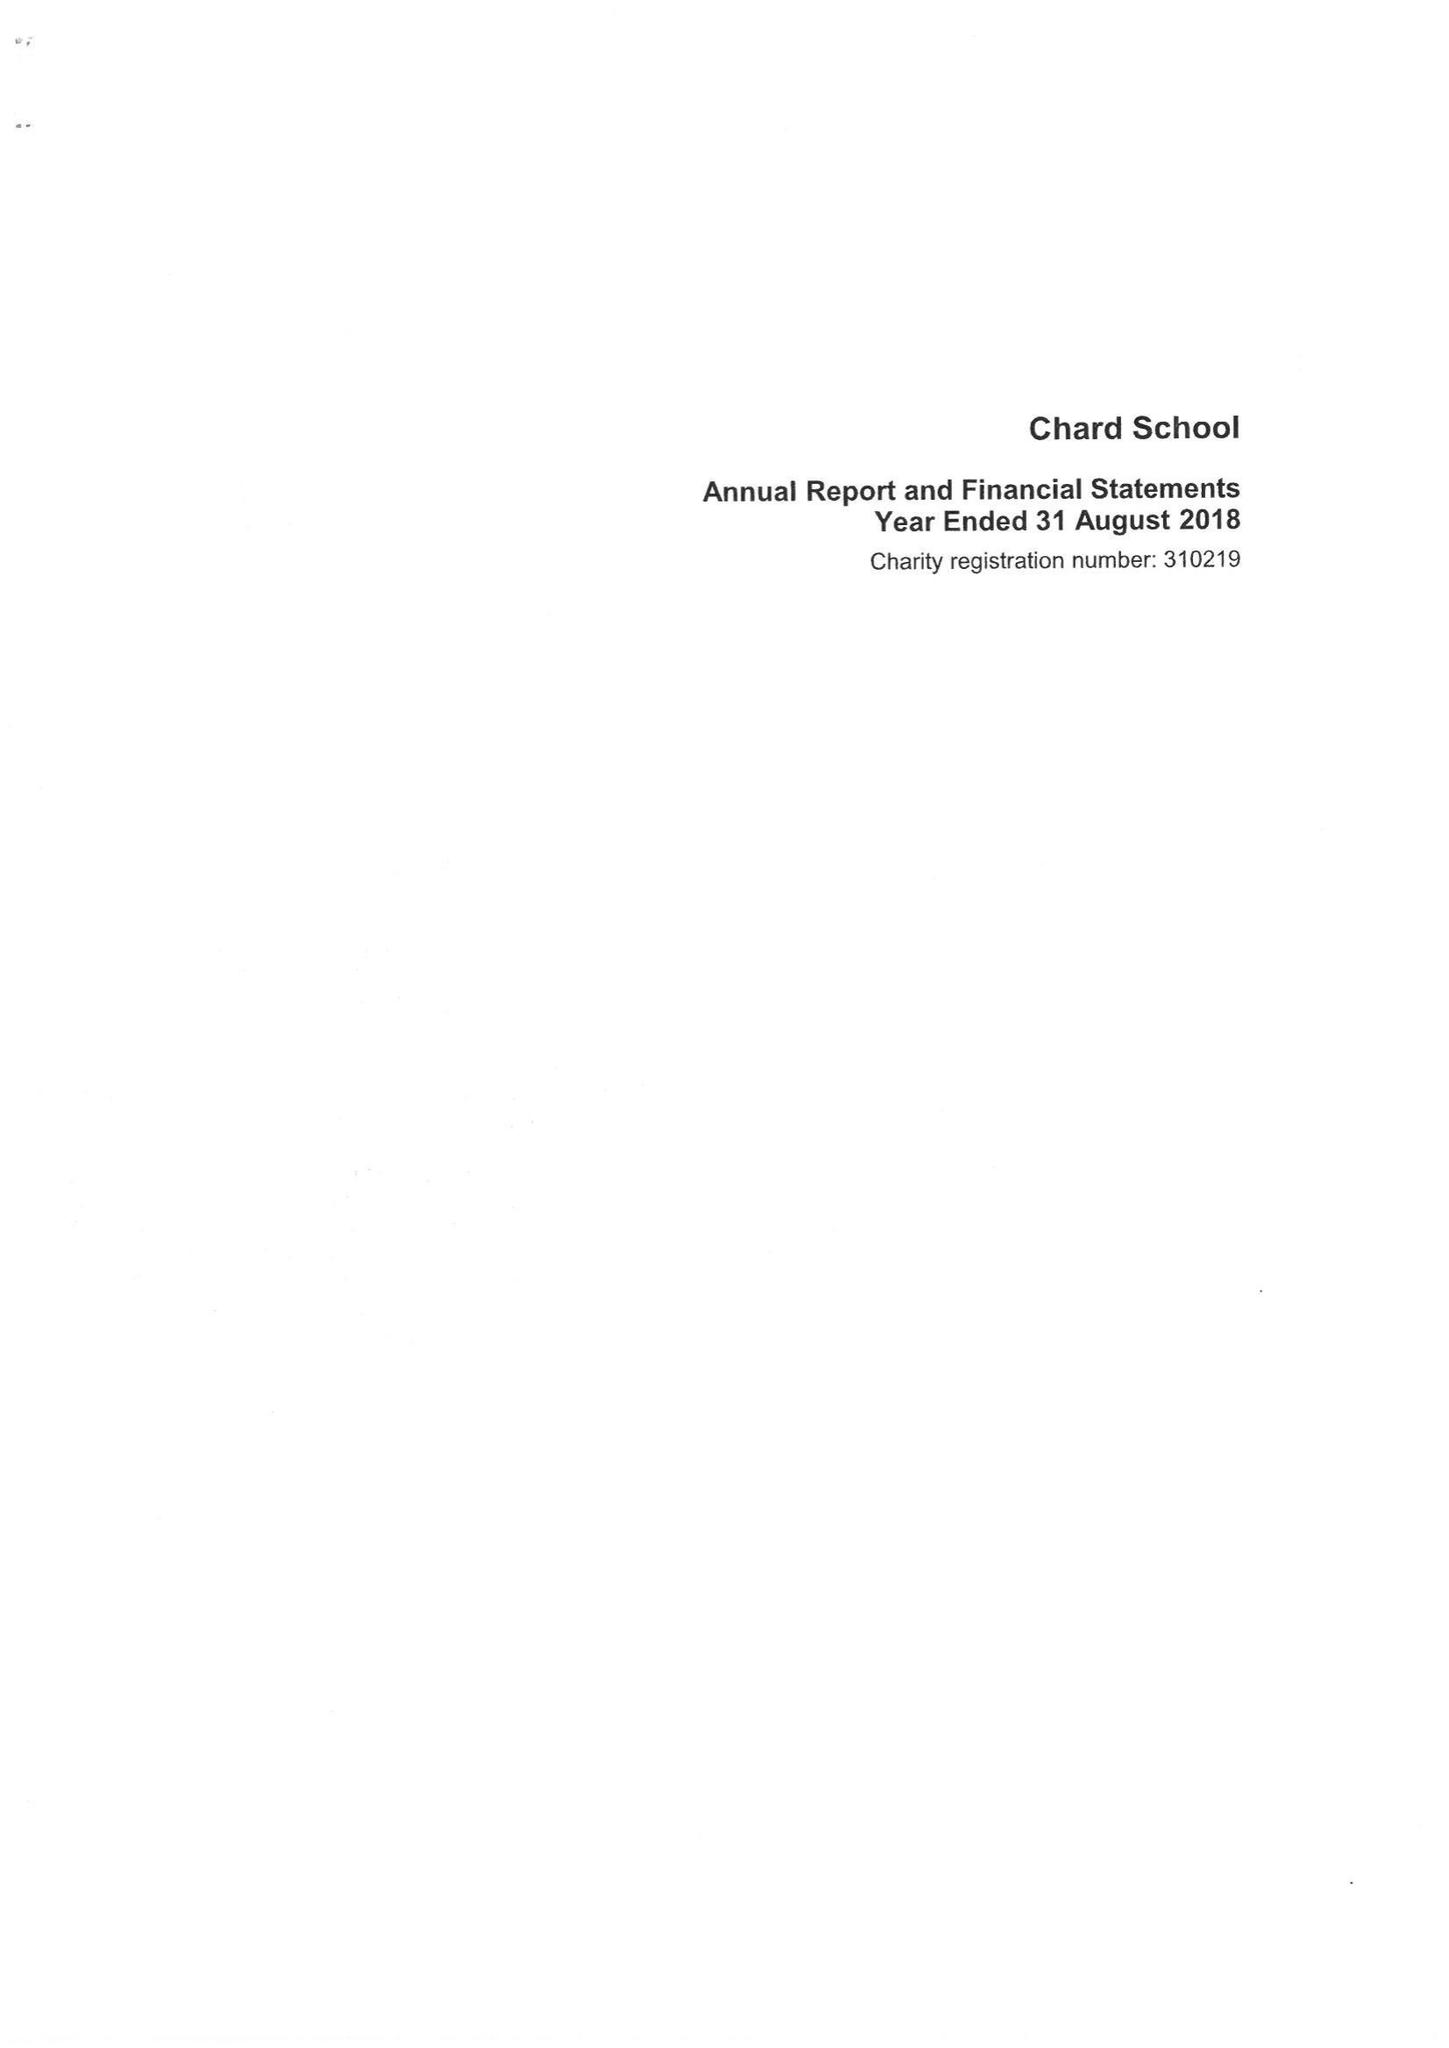What is the value for the spending_annually_in_british_pounds?
Answer the question using a single word or phrase. 472209.00 